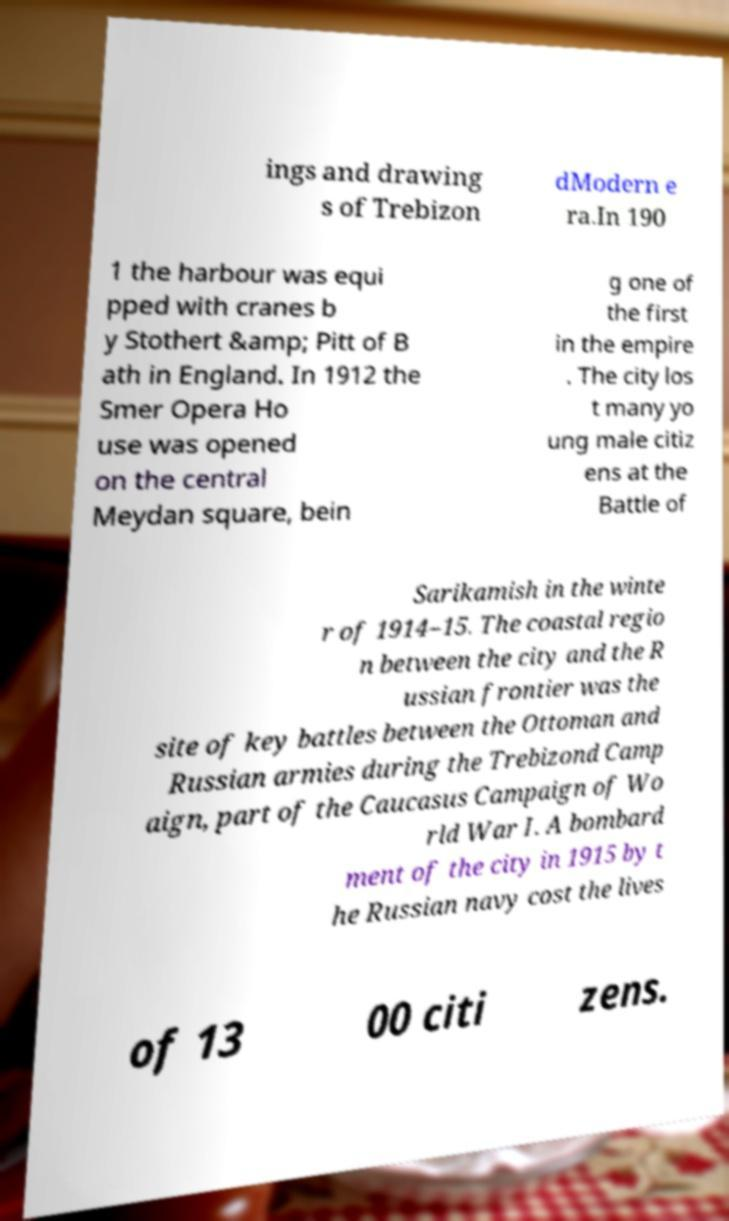Can you accurately transcribe the text from the provided image for me? ings and drawing s of Trebizon dModern e ra.In 190 1 the harbour was equi pped with cranes b y Stothert &amp; Pitt of B ath in England. In 1912 the Smer Opera Ho use was opened on the central Meydan square, bein g one of the first in the empire . The city los t many yo ung male citiz ens at the Battle of Sarikamish in the winte r of 1914–15. The coastal regio n between the city and the R ussian frontier was the site of key battles between the Ottoman and Russian armies during the Trebizond Camp aign, part of the Caucasus Campaign of Wo rld War I. A bombard ment of the city in 1915 by t he Russian navy cost the lives of 13 00 citi zens. 